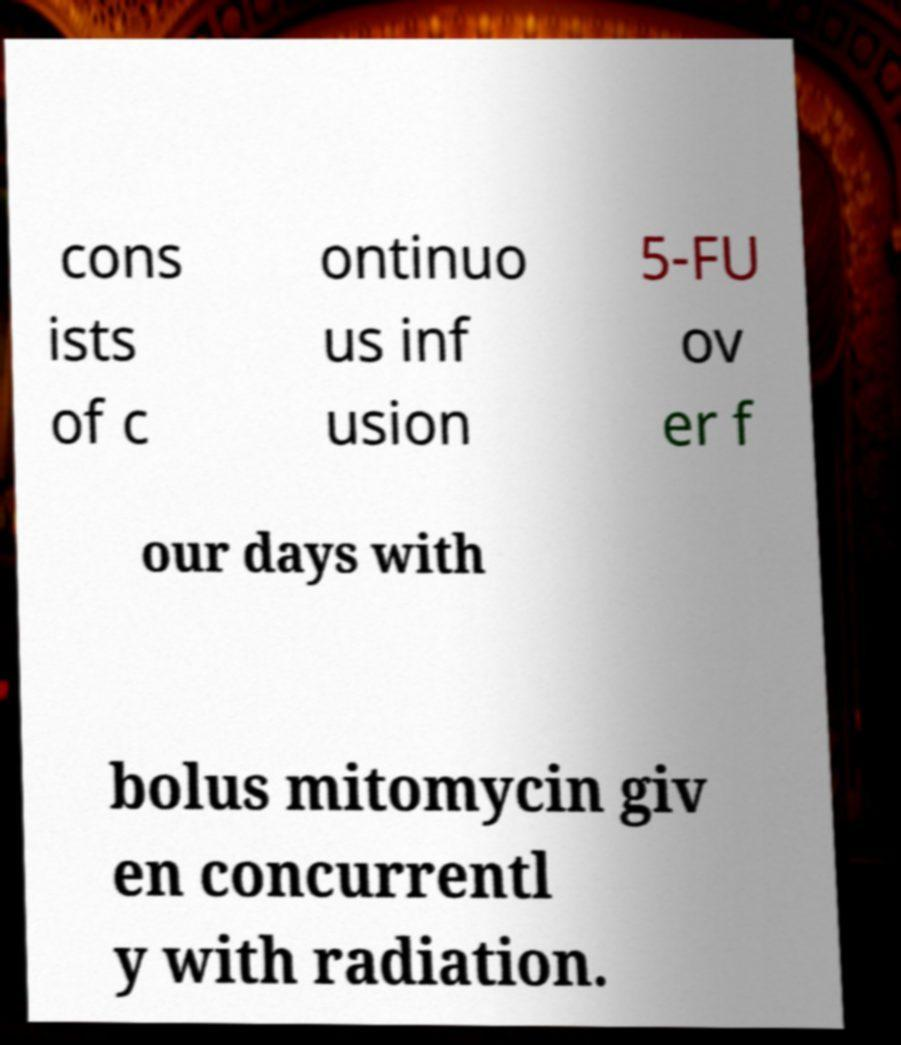What messages or text are displayed in this image? I need them in a readable, typed format. cons ists of c ontinuo us inf usion 5-FU ov er f our days with bolus mitomycin giv en concurrentl y with radiation. 